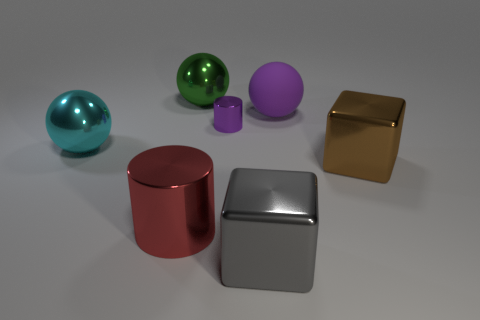The tiny shiny thing that is the same color as the rubber object is what shape?
Offer a very short reply. Cylinder. Do the big brown metal thing and the gray metallic object have the same shape?
Give a very brief answer. Yes. There is a cylinder that is in front of the large block that is right of the matte object; what color is it?
Ensure brevity in your answer.  Red. There is a ball that is both in front of the green metal thing and left of the purple metallic cylinder; what is its size?
Your answer should be very brief. Large. Is there any other thing that has the same color as the small cylinder?
Provide a short and direct response. Yes. What shape is the red object that is the same material as the big gray block?
Your answer should be very brief. Cylinder. Do the small purple metal thing and the large metallic thing that is behind the small purple thing have the same shape?
Make the answer very short. No. The large sphere that is to the left of the cylinder in front of the brown metallic object is made of what material?
Make the answer very short. Metal. Are there an equal number of metallic blocks that are in front of the brown cube and tiny gray spheres?
Your response must be concise. No. Are there any other things that have the same material as the small thing?
Your answer should be very brief. Yes. 